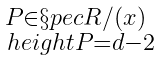<formula> <loc_0><loc_0><loc_500><loc_500>\begin{smallmatrix} P \in \S p e c R / ( x ) \\ \ h e i g h t P = d - 2 \end{smallmatrix}</formula> 